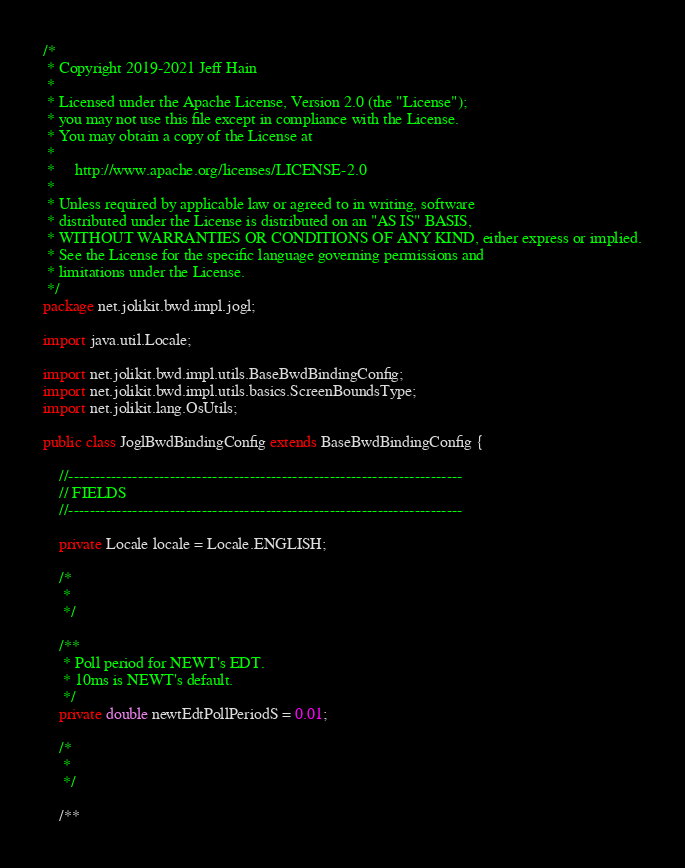<code> <loc_0><loc_0><loc_500><loc_500><_Java_>/*
 * Copyright 2019-2021 Jeff Hain
 *
 * Licensed under the Apache License, Version 2.0 (the "License");
 * you may not use this file except in compliance with the License.
 * You may obtain a copy of the License at
 *
 *     http://www.apache.org/licenses/LICENSE-2.0
 *
 * Unless required by applicable law or agreed to in writing, software
 * distributed under the License is distributed on an "AS IS" BASIS,
 * WITHOUT WARRANTIES OR CONDITIONS OF ANY KIND, either express or implied.
 * See the License for the specific language governing permissions and
 * limitations under the License.
 */
package net.jolikit.bwd.impl.jogl;

import java.util.Locale;

import net.jolikit.bwd.impl.utils.BaseBwdBindingConfig;
import net.jolikit.bwd.impl.utils.basics.ScreenBoundsType;
import net.jolikit.lang.OsUtils;

public class JoglBwdBindingConfig extends BaseBwdBindingConfig {

    //--------------------------------------------------------------------------
    // FIELDS
    //--------------------------------------------------------------------------

    private Locale locale = Locale.ENGLISH;
    
    /*
     * 
     */
    
    /**
     * Poll period for NEWT's EDT.
     * 10ms is NEWT's default.
     */
    private double newtEdtPollPeriodS = 0.01;

    /*
     * 
     */
    
    /**</code> 